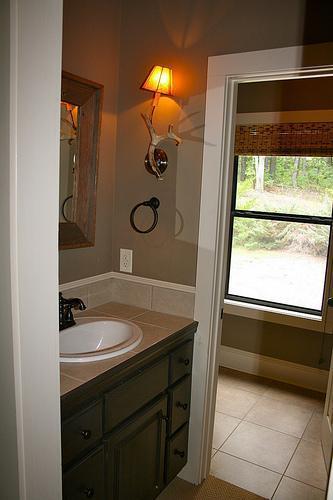How many people are in the photo?
Give a very brief answer. 0. 